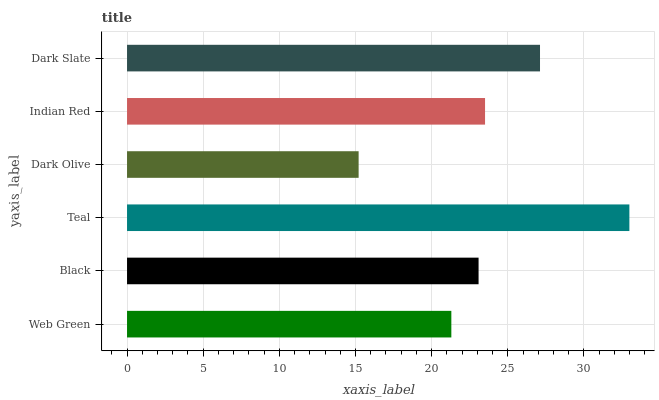Is Dark Olive the minimum?
Answer yes or no. Yes. Is Teal the maximum?
Answer yes or no. Yes. Is Black the minimum?
Answer yes or no. No. Is Black the maximum?
Answer yes or no. No. Is Black greater than Web Green?
Answer yes or no. Yes. Is Web Green less than Black?
Answer yes or no. Yes. Is Web Green greater than Black?
Answer yes or no. No. Is Black less than Web Green?
Answer yes or no. No. Is Indian Red the high median?
Answer yes or no. Yes. Is Black the low median?
Answer yes or no. Yes. Is Web Green the high median?
Answer yes or no. No. Is Dark Olive the low median?
Answer yes or no. No. 